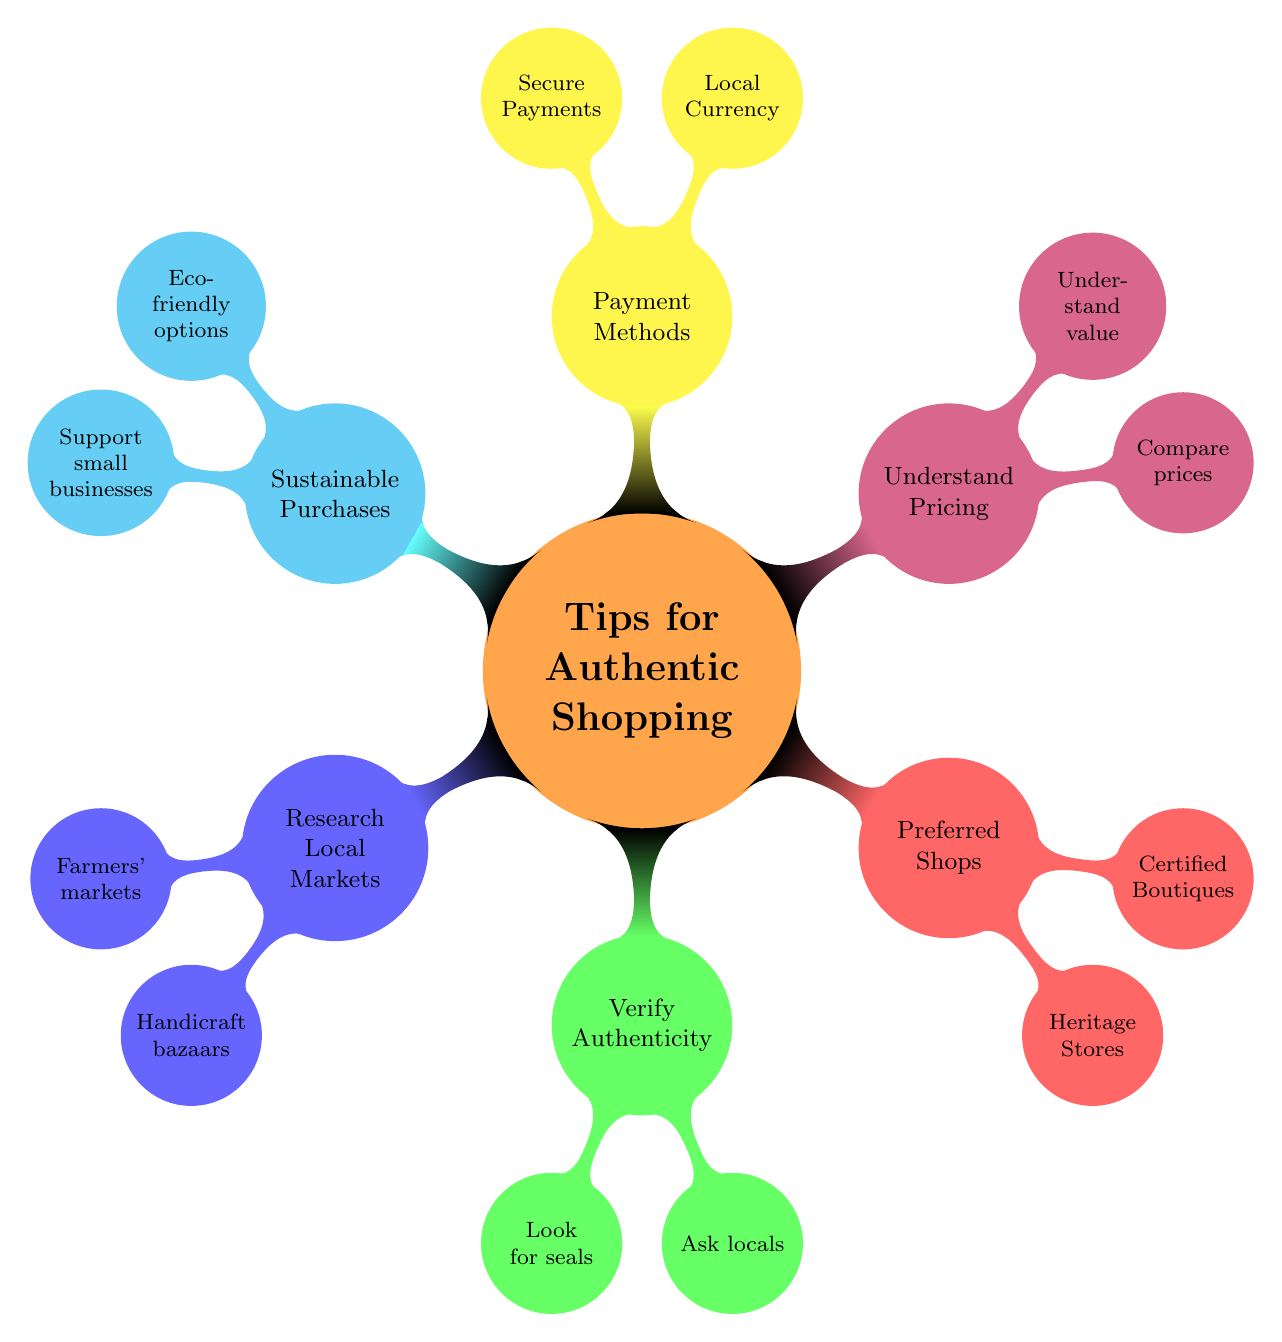What are the two types of local markets mentioned? The diagram outlines two types of local markets: farmers' markets and handicraft bazaars. These are child nodes under the "Research Local Markets" node.
Answer: farmers' markets, handicraft bazaars How many main categories are there in the mind map? The mind map consists of six main categories: Research Local Markets, Verify Authenticity, Preferred Shops, Understand Pricing, Payment Methods, and Sustainable Purchases. Counting these gives a total of six main nodes.
Answer: 6 What should you look for to verify authenticity? According to the diagram, you should look for seals that indicate authenticity, specifically the 'Genuine Local Product' seal mentioned under the "Verify Authenticity" section.
Answer: seals Which shop is recommended for traditional wear? The diagram indicates that Thompson's Heritage Shop is the preferred shop for traditional wear, as listed under the "Preferred Shops" category.
Answer: Thompson's Heritage Shop What is an eco-friendly shopping option mentioned in the diagram? The diagram specifically mentions Green Earth Traders as a shop where you can find eco-friendly options, listed under the "Sustainable Purchases" category.
Answer: Green Earth Traders How do you compare prices according to the diagram? The diagram suggests comparing similar items across different shops, particularly at Kensington Plaza, which is specifically noted under the "Understand Pricing" section.
Answer: Kensington Plaza Which payment method is advised to use? The diagram advises using credit cards with security chips, which are recommended under the "Payment Methods" category.
Answer: credit cards with security chips What strategy is suggested to support the local economy? The mind map suggests purchasing from small vendors at Greenway Street Market as a strategy to support the local economy, noted under the "Sustainable Purchases" section.
Answer: small vendors at Greenway Street Market 